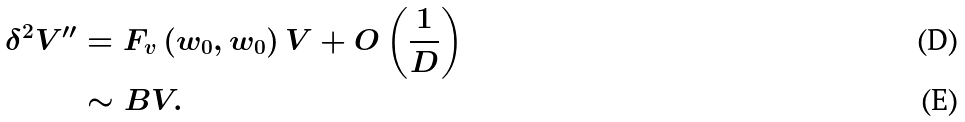Convert formula to latex. <formula><loc_0><loc_0><loc_500><loc_500>\delta ^ { 2 } V ^ { \prime \prime } & = F _ { v } \left ( w _ { 0 } , w _ { 0 } \right ) V + O \left ( \frac { 1 } { D } \right ) \\ & \sim B V .</formula> 